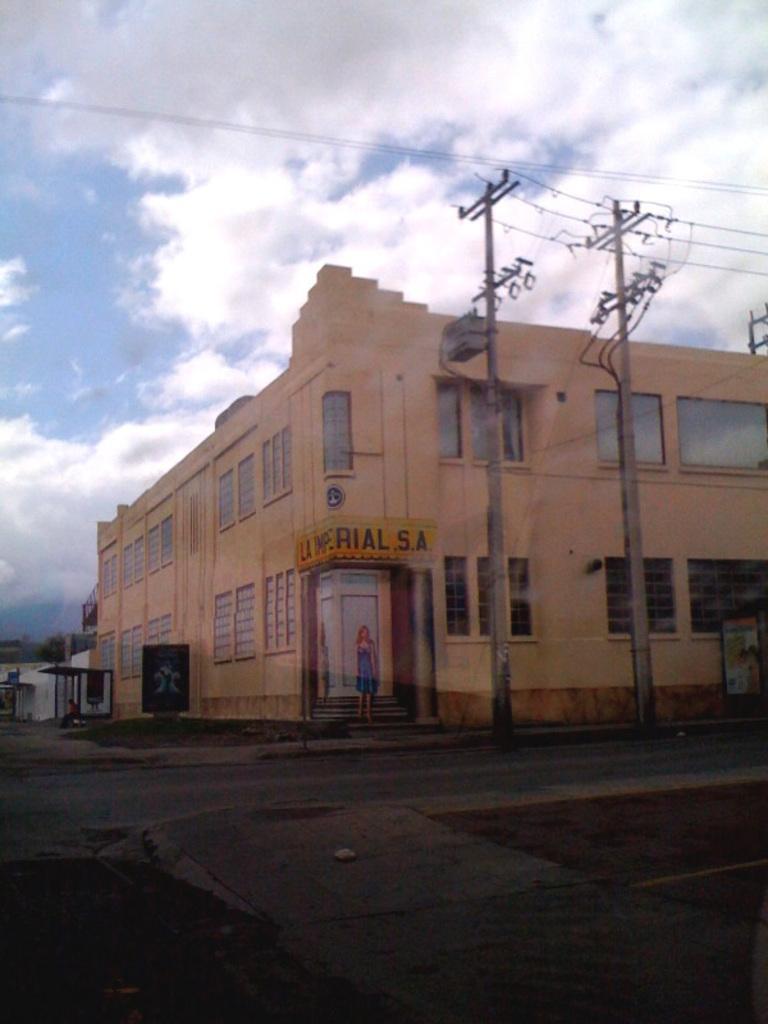How would you summarize this image in a sentence or two? In the image there is a building and around the building there is a plain road, on the right side there are two current poles. 